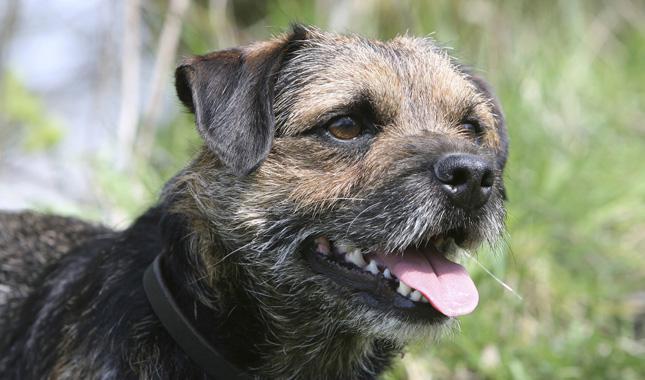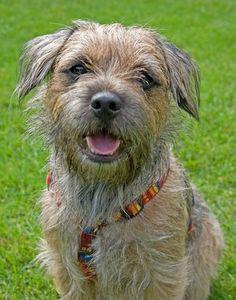The first image is the image on the left, the second image is the image on the right. Given the left and right images, does the statement "All the dogs have a visible collar on." hold true? Answer yes or no. Yes. The first image is the image on the left, the second image is the image on the right. For the images shown, is this caption "a circular metal dog tag is attached to the dogs collar" true? Answer yes or no. No. 